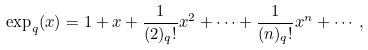Convert formula to latex. <formula><loc_0><loc_0><loc_500><loc_500>\exp _ { q } ( x ) = 1 + x + \frac { 1 } { ( 2 ) _ { q } ! } x ^ { 2 } + \cdots + \frac { 1 } { ( n ) _ { q } ! } x ^ { n } + \cdots ,</formula> 